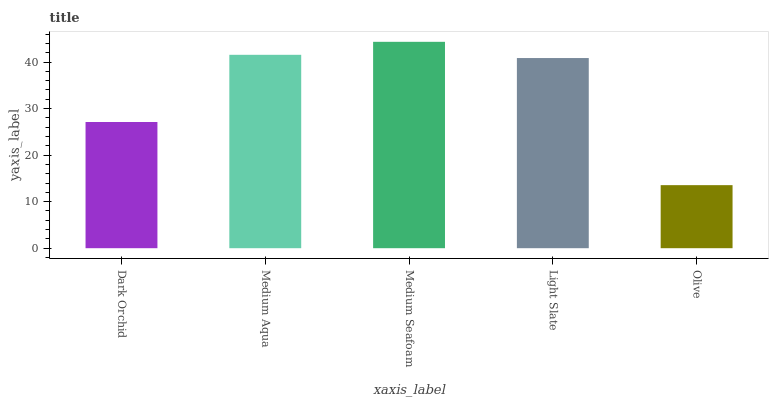Is Medium Aqua the minimum?
Answer yes or no. No. Is Medium Aqua the maximum?
Answer yes or no. No. Is Medium Aqua greater than Dark Orchid?
Answer yes or no. Yes. Is Dark Orchid less than Medium Aqua?
Answer yes or no. Yes. Is Dark Orchid greater than Medium Aqua?
Answer yes or no. No. Is Medium Aqua less than Dark Orchid?
Answer yes or no. No. Is Light Slate the high median?
Answer yes or no. Yes. Is Light Slate the low median?
Answer yes or no. Yes. Is Dark Orchid the high median?
Answer yes or no. No. Is Medium Aqua the low median?
Answer yes or no. No. 